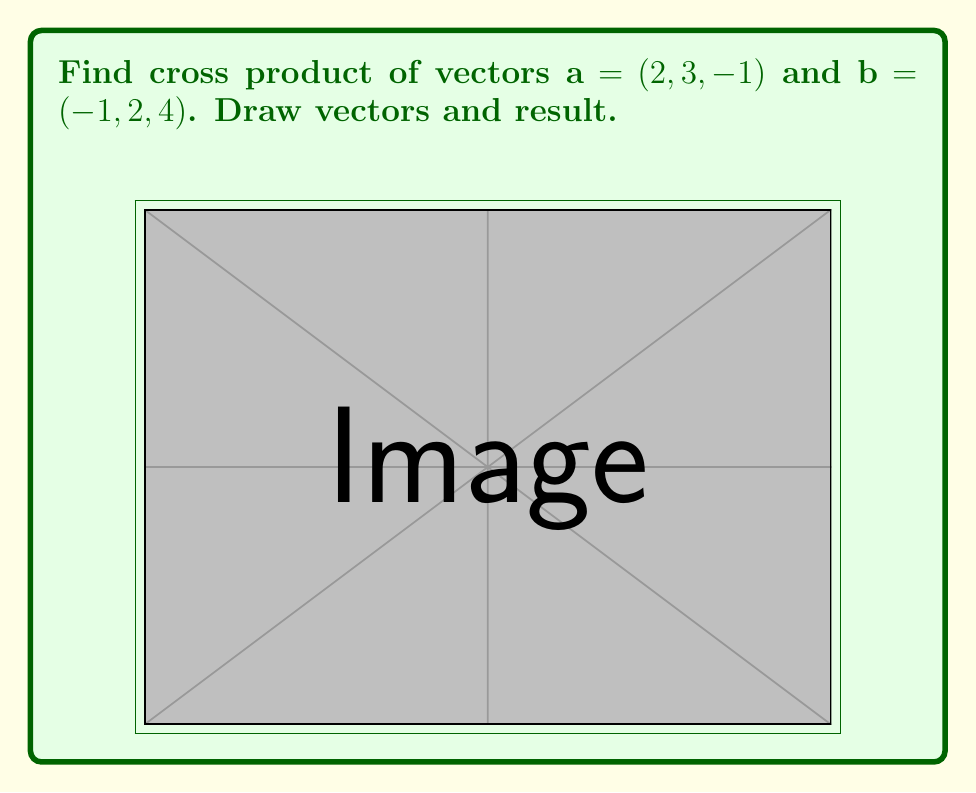Can you solve this math problem? 1) Cross product formula: $\mathbf{a} \times \mathbf{b} = (a_2b_3 - a_3b_2, a_3b_1 - a_1b_3, a_1b_2 - a_2b_1)$

2) Put values:
   $\mathbf{a} = (2, 3, -1)$, $\mathbf{b} = (-1, 2, 4)$

3) Calculate each part:
   $(3 \cdot 4 - (-1) \cdot 2, (-1) \cdot (-1) - 2 \cdot 4, 2 \cdot 2 - 3 \cdot (-1))$

4) Simplify:
   $(12 - (-2), 1 - 8, 4 - (-3))$

5) Final result:
   $(14, -7, 7)$

6) Simplify by common factor:
   $7(2, -1, 1)$

7) Check: $\mathbf{a} \times \mathbf{b}$ is perpendicular to both $\mathbf{a}$ and $\mathbf{b}$
Answer: $\mathbf{a} \times \mathbf{b} = 7(2, -1, 1)$ 